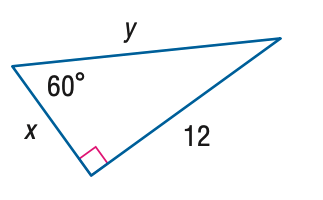Answer the mathemtical geometry problem and directly provide the correct option letter.
Question: Find x.
Choices: A: 4 \sqrt { 2 } B: 4 \sqrt { 3 } C: 8 \sqrt { 2 } D: 8 \sqrt { 3 } B 